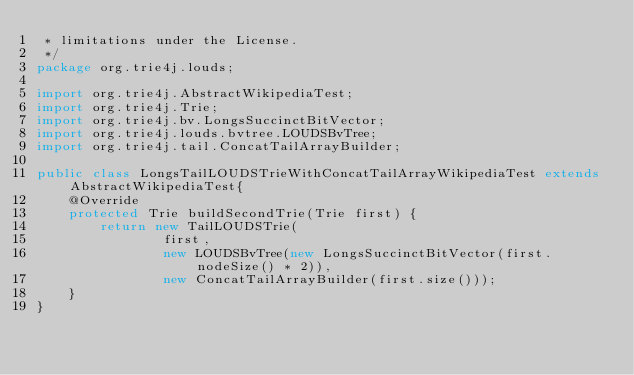<code> <loc_0><loc_0><loc_500><loc_500><_Java_> * limitations under the License.
 */
package org.trie4j.louds;

import org.trie4j.AbstractWikipediaTest;
import org.trie4j.Trie;
import org.trie4j.bv.LongsSuccinctBitVector;
import org.trie4j.louds.bvtree.LOUDSBvTree;
import org.trie4j.tail.ConcatTailArrayBuilder;

public class LongsTailLOUDSTrieWithConcatTailArrayWikipediaTest extends AbstractWikipediaTest{
	@Override
	protected Trie buildSecondTrie(Trie first) {
		return new TailLOUDSTrie(
				first,
				new LOUDSBvTree(new LongsSuccinctBitVector(first.nodeSize() * 2)),
				new ConcatTailArrayBuilder(first.size()));
	}
}
</code> 